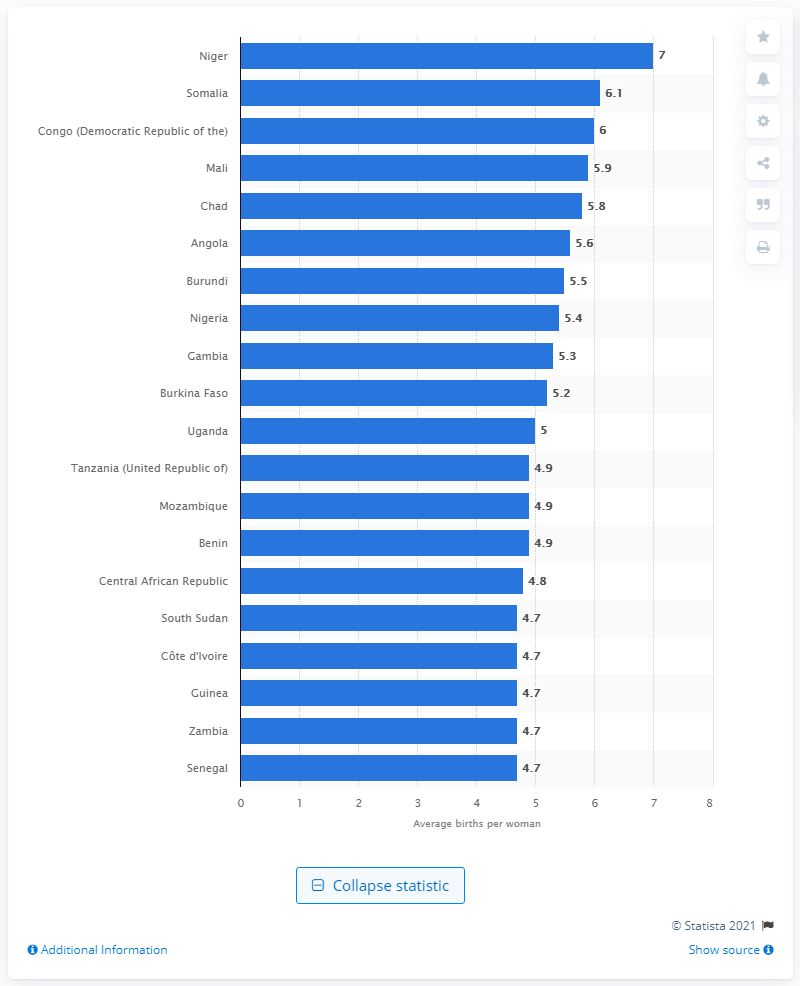What country had the highest average birth rate per woman in the world? According to the presented bar chart, Niger has the highest average birth rate per woman in the world, with a rate of approximately 7 children per woman. This figure emphasizes the country's considerably high fertility rate in contrast to other nations listed. 